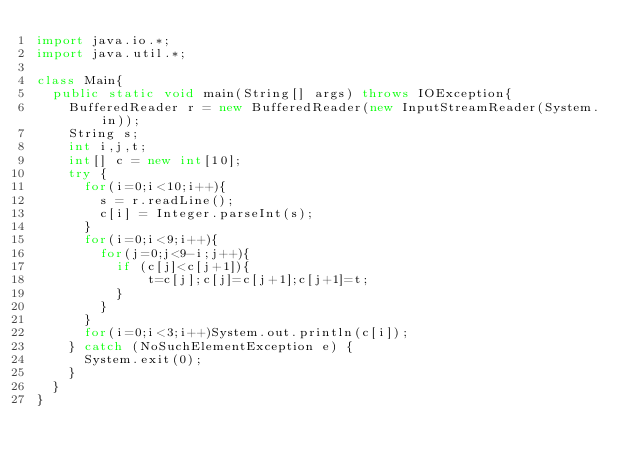Convert code to text. <code><loc_0><loc_0><loc_500><loc_500><_Java_>import java.io.*;
import java.util.*;

class Main{
	public static void main(String[] args) throws IOException{
		BufferedReader r = new BufferedReader(new InputStreamReader(System.in));
		String s;
		int i,j,t;
		int[] c = new int[10];
		try {
			for(i=0;i<10;i++){
				s = r.readLine();
				c[i] = Integer.parseInt(s);
			}
			for(i=0;i<9;i++){
				for(j=0;j<9-i;j++){
					if (c[j]<c[j+1]){
							t=c[j];c[j]=c[j+1];c[j+1]=t;
					}
				}
			}
			for(i=0;i<3;i++)System.out.println(c[i]);
		} catch (NoSuchElementException e) {
			System.exit(0);
		}
	}
}</code> 